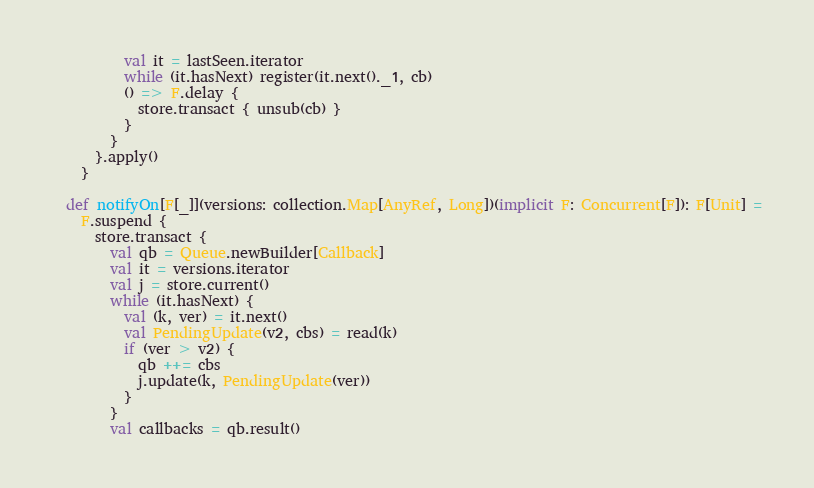<code> <loc_0><loc_0><loc_500><loc_500><_Scala_>          val it = lastSeen.iterator
          while (it.hasNext) register(it.next()._1, cb)
          () => F.delay {
            store.transact { unsub(cb) }
          }
        }
      }.apply()
    }

  def notifyOn[F[_]](versions: collection.Map[AnyRef, Long])(implicit F: Concurrent[F]): F[Unit] =
    F.suspend {
      store.transact {
        val qb = Queue.newBuilder[Callback]
        val it = versions.iterator
        val j = store.current()
        while (it.hasNext) {
          val (k, ver) = it.next()
          val PendingUpdate(v2, cbs) = read(k)
          if (ver > v2) {
            qb ++= cbs
            j.update(k, PendingUpdate(ver))
          }
        }
        val callbacks = qb.result()</code> 